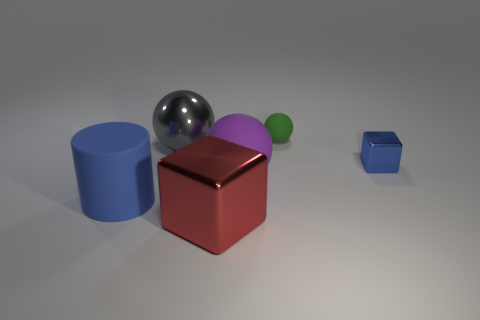Add 2 gray objects. How many objects exist? 8 Subtract all cylinders. How many objects are left? 5 Add 4 blue cylinders. How many blue cylinders are left? 5 Add 6 blue cylinders. How many blue cylinders exist? 7 Subtract 0 gray cylinders. How many objects are left? 6 Subtract all big red things. Subtract all large metallic things. How many objects are left? 3 